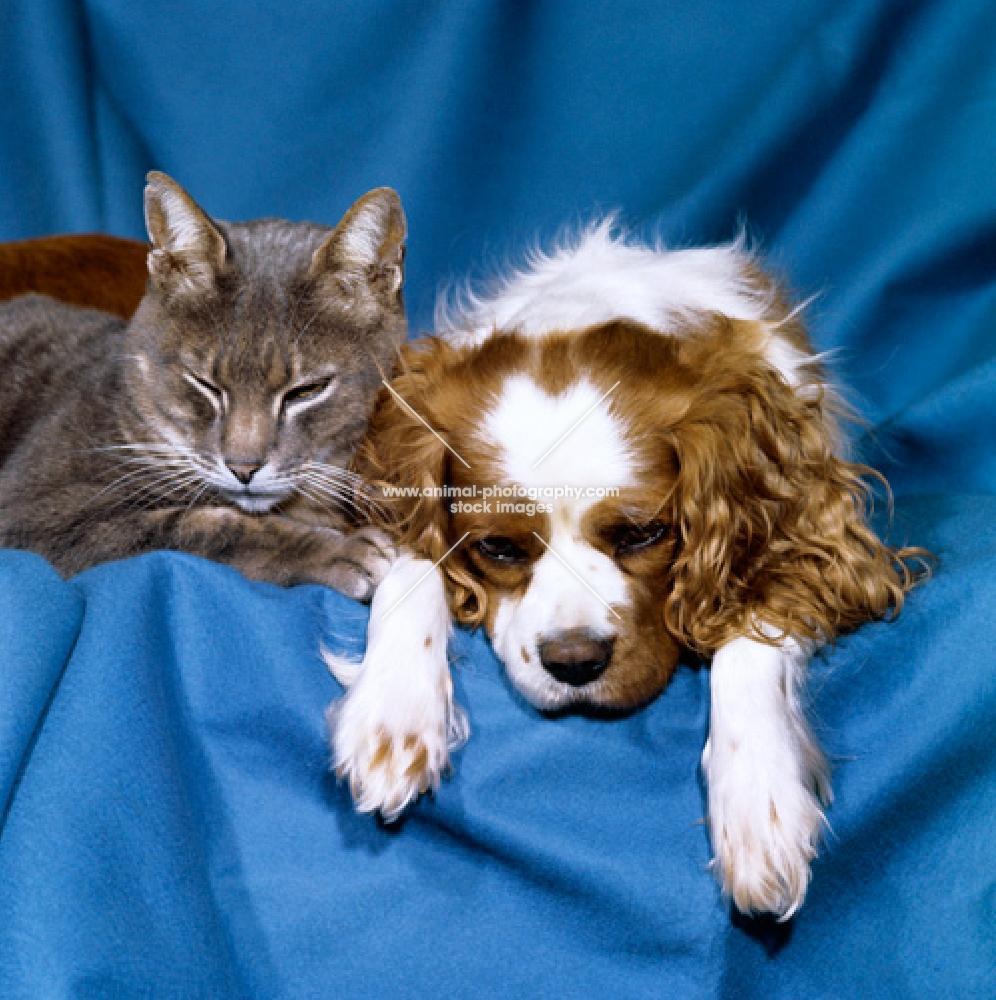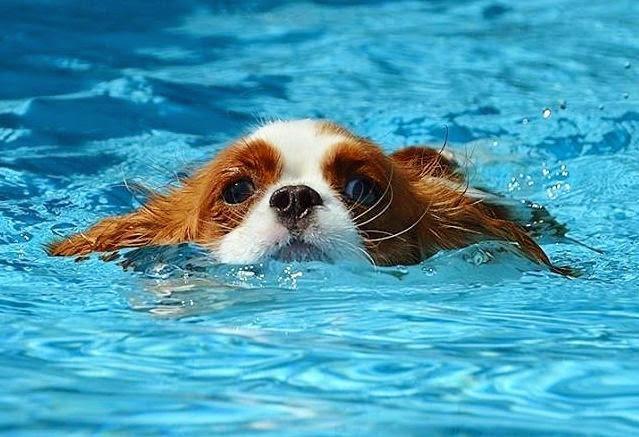The first image is the image on the left, the second image is the image on the right. Examine the images to the left and right. Is the description "There are three mammals visible" accurate? Answer yes or no. Yes. The first image is the image on the left, the second image is the image on the right. Given the left and right images, does the statement "There is a single dog outside in each image." hold true? Answer yes or no. No. 